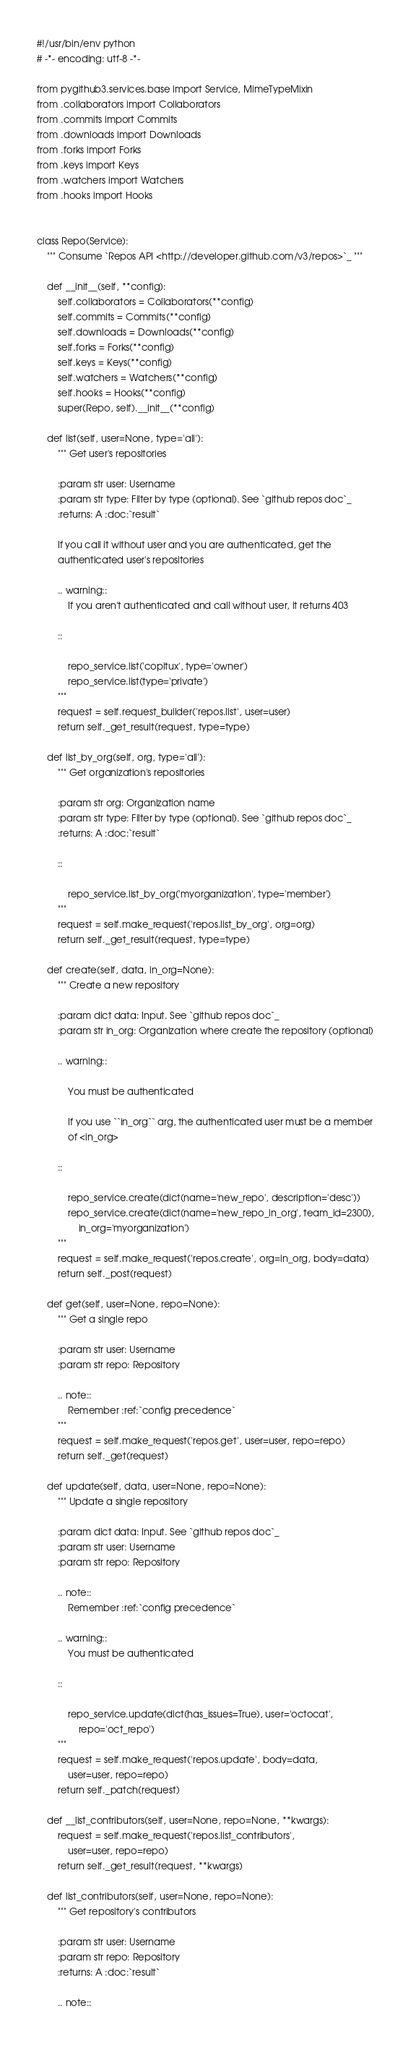<code> <loc_0><loc_0><loc_500><loc_500><_Python_>#!/usr/bin/env python
# -*- encoding: utf-8 -*-

from pygithub3.services.base import Service, MimeTypeMixin
from .collaborators import Collaborators
from .commits import Commits
from .downloads import Downloads
from .forks import Forks
from .keys import Keys
from .watchers import Watchers
from .hooks import Hooks


class Repo(Service):
    """ Consume `Repos API <http://developer.github.com/v3/repos>`_ """

    def __init__(self, **config):
        self.collaborators = Collaborators(**config)
        self.commits = Commits(**config)
        self.downloads = Downloads(**config)
        self.forks = Forks(**config)
        self.keys = Keys(**config)
        self.watchers = Watchers(**config)
        self.hooks = Hooks(**config)
        super(Repo, self).__init__(**config)

    def list(self, user=None, type='all'):
        """ Get user's repositories

        :param str user: Username
        :param str type: Filter by type (optional). See `github repos doc`_
        :returns: A :doc:`result`

        If you call it without user and you are authenticated, get the
        authenticated user's repositories

        .. warning::
            If you aren't authenticated and call without user, it returns 403

        ::

            repo_service.list('copitux', type='owner')
            repo_service.list(type='private')
        """
        request = self.request_builder('repos.list', user=user)
        return self._get_result(request, type=type)

    def list_by_org(self, org, type='all'):
        """ Get organization's repositories

        :param str org: Organization name
        :param str type: Filter by type (optional). See `github repos doc`_
        :returns: A :doc:`result`

        ::

            repo_service.list_by_org('myorganization', type='member')
        """
        request = self.make_request('repos.list_by_org', org=org)
        return self._get_result(request, type=type)

    def create(self, data, in_org=None):
        """ Create a new repository

        :param dict data: Input. See `github repos doc`_
        :param str in_org: Organization where create the repository (optional)

        .. warning::

            You must be authenticated

            If you use ``in_org`` arg, the authenticated user must be a member
            of <in_org>

        ::

            repo_service.create(dict(name='new_repo', description='desc'))
            repo_service.create(dict(name='new_repo_in_org', team_id=2300),
                in_org='myorganization')
        """
        request = self.make_request('repos.create', org=in_org, body=data)
        return self._post(request)

    def get(self, user=None, repo=None):
        """ Get a single repo

        :param str user: Username
        :param str repo: Repository

        .. note::
            Remember :ref:`config precedence`
        """
        request = self.make_request('repos.get', user=user, repo=repo)
        return self._get(request)

    def update(self, data, user=None, repo=None):
        """ Update a single repository

        :param dict data: Input. See `github repos doc`_
        :param str user: Username
        :param str repo: Repository

        .. note::
            Remember :ref:`config precedence`

        .. warning::
            You must be authenticated

        ::

            repo_service.update(dict(has_issues=True), user='octocat',
                repo='oct_repo')
        """
        request = self.make_request('repos.update', body=data,
            user=user, repo=repo)
        return self._patch(request)

    def __list_contributors(self, user=None, repo=None, **kwargs):
        request = self.make_request('repos.list_contributors',
            user=user, repo=repo)
        return self._get_result(request, **kwargs)

    def list_contributors(self, user=None, repo=None):
        """ Get repository's contributors

        :param str user: Username
        :param str repo: Repository
        :returns: A :doc:`result`

        .. note::</code> 